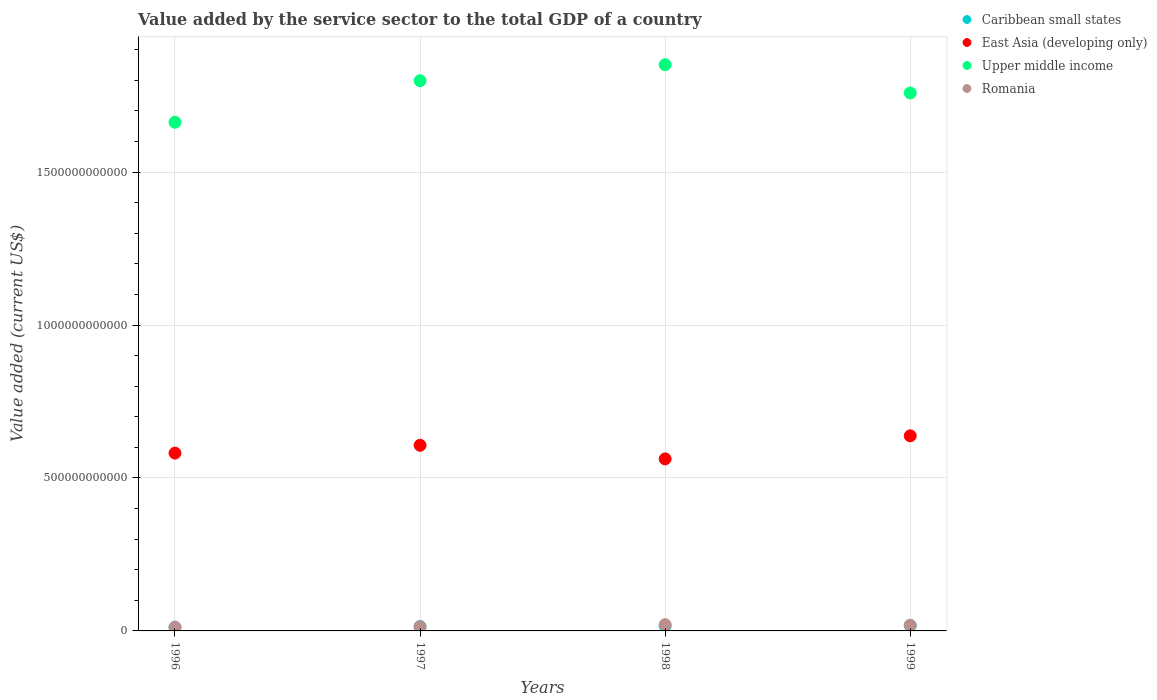How many different coloured dotlines are there?
Keep it short and to the point. 4. Is the number of dotlines equal to the number of legend labels?
Make the answer very short. Yes. What is the value added by the service sector to the total GDP in Romania in 1999?
Provide a short and direct response. 1.86e+1. Across all years, what is the maximum value added by the service sector to the total GDP in Romania?
Keep it short and to the point. 2.05e+1. Across all years, what is the minimum value added by the service sector to the total GDP in Romania?
Give a very brief answer. 1.22e+1. What is the total value added by the service sector to the total GDP in East Asia (developing only) in the graph?
Offer a very short reply. 2.39e+12. What is the difference between the value added by the service sector to the total GDP in Upper middle income in 1996 and that in 1998?
Ensure brevity in your answer.  -1.88e+11. What is the difference between the value added by the service sector to the total GDP in East Asia (developing only) in 1998 and the value added by the service sector to the total GDP in Romania in 1999?
Offer a terse response. 5.44e+11. What is the average value added by the service sector to the total GDP in Caribbean small states per year?
Offer a terse response. 1.50e+1. In the year 1996, what is the difference between the value added by the service sector to the total GDP in East Asia (developing only) and value added by the service sector to the total GDP in Romania?
Provide a short and direct response. 5.69e+11. In how many years, is the value added by the service sector to the total GDP in Upper middle income greater than 500000000000 US$?
Your answer should be compact. 4. What is the ratio of the value added by the service sector to the total GDP in Romania in 1998 to that in 1999?
Offer a terse response. 1.1. Is the value added by the service sector to the total GDP in Upper middle income in 1997 less than that in 1999?
Your response must be concise. No. Is the difference between the value added by the service sector to the total GDP in East Asia (developing only) in 1996 and 1998 greater than the difference between the value added by the service sector to the total GDP in Romania in 1996 and 1998?
Make the answer very short. Yes. What is the difference between the highest and the second highest value added by the service sector to the total GDP in East Asia (developing only)?
Provide a succinct answer. 3.09e+1. What is the difference between the highest and the lowest value added by the service sector to the total GDP in Romania?
Give a very brief answer. 8.25e+09. Is the sum of the value added by the service sector to the total GDP in Romania in 1996 and 1997 greater than the maximum value added by the service sector to the total GDP in East Asia (developing only) across all years?
Offer a very short reply. No. Is it the case that in every year, the sum of the value added by the service sector to the total GDP in Caribbean small states and value added by the service sector to the total GDP in Upper middle income  is greater than the sum of value added by the service sector to the total GDP in East Asia (developing only) and value added by the service sector to the total GDP in Romania?
Give a very brief answer. Yes. Is the value added by the service sector to the total GDP in East Asia (developing only) strictly greater than the value added by the service sector to the total GDP in Romania over the years?
Your answer should be compact. Yes. Is the value added by the service sector to the total GDP in Caribbean small states strictly less than the value added by the service sector to the total GDP in Upper middle income over the years?
Your answer should be compact. Yes. How many dotlines are there?
Your answer should be compact. 4. What is the difference between two consecutive major ticks on the Y-axis?
Your answer should be very brief. 5.00e+11. Are the values on the major ticks of Y-axis written in scientific E-notation?
Give a very brief answer. No. Does the graph contain any zero values?
Keep it short and to the point. No. Does the graph contain grids?
Give a very brief answer. Yes. Where does the legend appear in the graph?
Give a very brief answer. Top right. What is the title of the graph?
Ensure brevity in your answer.  Value added by the service sector to the total GDP of a country. Does "Sao Tome and Principe" appear as one of the legend labels in the graph?
Your answer should be compact. No. What is the label or title of the X-axis?
Give a very brief answer. Years. What is the label or title of the Y-axis?
Your response must be concise. Value added (current US$). What is the Value added (current US$) of Caribbean small states in 1996?
Your response must be concise. 1.20e+1. What is the Value added (current US$) in East Asia (developing only) in 1996?
Your answer should be compact. 5.81e+11. What is the Value added (current US$) in Upper middle income in 1996?
Give a very brief answer. 1.66e+12. What is the Value added (current US$) in Romania in 1996?
Your answer should be very brief. 1.22e+1. What is the Value added (current US$) in Caribbean small states in 1997?
Give a very brief answer. 1.42e+1. What is the Value added (current US$) in East Asia (developing only) in 1997?
Keep it short and to the point. 6.07e+11. What is the Value added (current US$) of Upper middle income in 1997?
Make the answer very short. 1.80e+12. What is the Value added (current US$) of Romania in 1997?
Give a very brief answer. 1.34e+1. What is the Value added (current US$) of Caribbean small states in 1998?
Make the answer very short. 1.63e+1. What is the Value added (current US$) in East Asia (developing only) in 1998?
Provide a short and direct response. 5.62e+11. What is the Value added (current US$) in Upper middle income in 1998?
Provide a succinct answer. 1.85e+12. What is the Value added (current US$) of Romania in 1998?
Offer a very short reply. 2.05e+1. What is the Value added (current US$) in Caribbean small states in 1999?
Your answer should be very brief. 1.74e+1. What is the Value added (current US$) in East Asia (developing only) in 1999?
Keep it short and to the point. 6.38e+11. What is the Value added (current US$) in Upper middle income in 1999?
Make the answer very short. 1.76e+12. What is the Value added (current US$) of Romania in 1999?
Offer a very short reply. 1.86e+1. Across all years, what is the maximum Value added (current US$) in Caribbean small states?
Offer a terse response. 1.74e+1. Across all years, what is the maximum Value added (current US$) in East Asia (developing only)?
Offer a very short reply. 6.38e+11. Across all years, what is the maximum Value added (current US$) in Upper middle income?
Offer a very short reply. 1.85e+12. Across all years, what is the maximum Value added (current US$) of Romania?
Your answer should be very brief. 2.05e+1. Across all years, what is the minimum Value added (current US$) of Caribbean small states?
Provide a short and direct response. 1.20e+1. Across all years, what is the minimum Value added (current US$) in East Asia (developing only)?
Your answer should be very brief. 5.62e+11. Across all years, what is the minimum Value added (current US$) of Upper middle income?
Your answer should be compact. 1.66e+12. Across all years, what is the minimum Value added (current US$) in Romania?
Your answer should be compact. 1.22e+1. What is the total Value added (current US$) of Caribbean small states in the graph?
Your answer should be very brief. 5.99e+1. What is the total Value added (current US$) in East Asia (developing only) in the graph?
Give a very brief answer. 2.39e+12. What is the total Value added (current US$) in Upper middle income in the graph?
Offer a very short reply. 7.07e+12. What is the total Value added (current US$) of Romania in the graph?
Offer a very short reply. 6.47e+1. What is the difference between the Value added (current US$) of Caribbean small states in 1996 and that in 1997?
Offer a very short reply. -2.25e+09. What is the difference between the Value added (current US$) in East Asia (developing only) in 1996 and that in 1997?
Keep it short and to the point. -2.56e+1. What is the difference between the Value added (current US$) of Upper middle income in 1996 and that in 1997?
Your response must be concise. -1.36e+11. What is the difference between the Value added (current US$) in Romania in 1996 and that in 1997?
Provide a short and direct response. -1.17e+09. What is the difference between the Value added (current US$) in Caribbean small states in 1996 and that in 1998?
Offer a very short reply. -4.38e+09. What is the difference between the Value added (current US$) in East Asia (developing only) in 1996 and that in 1998?
Provide a short and direct response. 1.90e+1. What is the difference between the Value added (current US$) in Upper middle income in 1996 and that in 1998?
Offer a very short reply. -1.88e+11. What is the difference between the Value added (current US$) in Romania in 1996 and that in 1998?
Provide a succinct answer. -8.25e+09. What is the difference between the Value added (current US$) of Caribbean small states in 1996 and that in 1999?
Make the answer very short. -5.45e+09. What is the difference between the Value added (current US$) of East Asia (developing only) in 1996 and that in 1999?
Provide a short and direct response. -5.65e+1. What is the difference between the Value added (current US$) of Upper middle income in 1996 and that in 1999?
Your answer should be very brief. -9.57e+1. What is the difference between the Value added (current US$) of Romania in 1996 and that in 1999?
Offer a very short reply. -6.42e+09. What is the difference between the Value added (current US$) in Caribbean small states in 1997 and that in 1998?
Provide a succinct answer. -2.14e+09. What is the difference between the Value added (current US$) of East Asia (developing only) in 1997 and that in 1998?
Your response must be concise. 4.46e+1. What is the difference between the Value added (current US$) of Upper middle income in 1997 and that in 1998?
Your answer should be compact. -5.24e+1. What is the difference between the Value added (current US$) in Romania in 1997 and that in 1998?
Your response must be concise. -7.08e+09. What is the difference between the Value added (current US$) of Caribbean small states in 1997 and that in 1999?
Provide a succinct answer. -3.20e+09. What is the difference between the Value added (current US$) in East Asia (developing only) in 1997 and that in 1999?
Provide a succinct answer. -3.09e+1. What is the difference between the Value added (current US$) of Upper middle income in 1997 and that in 1999?
Your response must be concise. 4.00e+1. What is the difference between the Value added (current US$) of Romania in 1997 and that in 1999?
Make the answer very short. -5.25e+09. What is the difference between the Value added (current US$) of Caribbean small states in 1998 and that in 1999?
Ensure brevity in your answer.  -1.07e+09. What is the difference between the Value added (current US$) of East Asia (developing only) in 1998 and that in 1999?
Make the answer very short. -7.55e+1. What is the difference between the Value added (current US$) in Upper middle income in 1998 and that in 1999?
Offer a terse response. 9.24e+1. What is the difference between the Value added (current US$) in Romania in 1998 and that in 1999?
Your answer should be compact. 1.83e+09. What is the difference between the Value added (current US$) of Caribbean small states in 1996 and the Value added (current US$) of East Asia (developing only) in 1997?
Give a very brief answer. -5.95e+11. What is the difference between the Value added (current US$) in Caribbean small states in 1996 and the Value added (current US$) in Upper middle income in 1997?
Provide a succinct answer. -1.79e+12. What is the difference between the Value added (current US$) of Caribbean small states in 1996 and the Value added (current US$) of Romania in 1997?
Give a very brief answer. -1.43e+09. What is the difference between the Value added (current US$) of East Asia (developing only) in 1996 and the Value added (current US$) of Upper middle income in 1997?
Make the answer very short. -1.22e+12. What is the difference between the Value added (current US$) of East Asia (developing only) in 1996 and the Value added (current US$) of Romania in 1997?
Keep it short and to the point. 5.68e+11. What is the difference between the Value added (current US$) in Upper middle income in 1996 and the Value added (current US$) in Romania in 1997?
Your answer should be very brief. 1.65e+12. What is the difference between the Value added (current US$) of Caribbean small states in 1996 and the Value added (current US$) of East Asia (developing only) in 1998?
Your response must be concise. -5.50e+11. What is the difference between the Value added (current US$) in Caribbean small states in 1996 and the Value added (current US$) in Upper middle income in 1998?
Keep it short and to the point. -1.84e+12. What is the difference between the Value added (current US$) in Caribbean small states in 1996 and the Value added (current US$) in Romania in 1998?
Your response must be concise. -8.51e+09. What is the difference between the Value added (current US$) of East Asia (developing only) in 1996 and the Value added (current US$) of Upper middle income in 1998?
Provide a short and direct response. -1.27e+12. What is the difference between the Value added (current US$) of East Asia (developing only) in 1996 and the Value added (current US$) of Romania in 1998?
Give a very brief answer. 5.61e+11. What is the difference between the Value added (current US$) of Upper middle income in 1996 and the Value added (current US$) of Romania in 1998?
Offer a terse response. 1.64e+12. What is the difference between the Value added (current US$) in Caribbean small states in 1996 and the Value added (current US$) in East Asia (developing only) in 1999?
Provide a short and direct response. -6.26e+11. What is the difference between the Value added (current US$) in Caribbean small states in 1996 and the Value added (current US$) in Upper middle income in 1999?
Ensure brevity in your answer.  -1.75e+12. What is the difference between the Value added (current US$) in Caribbean small states in 1996 and the Value added (current US$) in Romania in 1999?
Keep it short and to the point. -6.68e+09. What is the difference between the Value added (current US$) in East Asia (developing only) in 1996 and the Value added (current US$) in Upper middle income in 1999?
Provide a short and direct response. -1.18e+12. What is the difference between the Value added (current US$) in East Asia (developing only) in 1996 and the Value added (current US$) in Romania in 1999?
Provide a succinct answer. 5.63e+11. What is the difference between the Value added (current US$) in Upper middle income in 1996 and the Value added (current US$) in Romania in 1999?
Your response must be concise. 1.64e+12. What is the difference between the Value added (current US$) in Caribbean small states in 1997 and the Value added (current US$) in East Asia (developing only) in 1998?
Offer a terse response. -5.48e+11. What is the difference between the Value added (current US$) of Caribbean small states in 1997 and the Value added (current US$) of Upper middle income in 1998?
Make the answer very short. -1.84e+12. What is the difference between the Value added (current US$) in Caribbean small states in 1997 and the Value added (current US$) in Romania in 1998?
Ensure brevity in your answer.  -6.27e+09. What is the difference between the Value added (current US$) of East Asia (developing only) in 1997 and the Value added (current US$) of Upper middle income in 1998?
Your answer should be compact. -1.24e+12. What is the difference between the Value added (current US$) of East Asia (developing only) in 1997 and the Value added (current US$) of Romania in 1998?
Ensure brevity in your answer.  5.86e+11. What is the difference between the Value added (current US$) in Upper middle income in 1997 and the Value added (current US$) in Romania in 1998?
Give a very brief answer. 1.78e+12. What is the difference between the Value added (current US$) of Caribbean small states in 1997 and the Value added (current US$) of East Asia (developing only) in 1999?
Provide a short and direct response. -6.24e+11. What is the difference between the Value added (current US$) in Caribbean small states in 1997 and the Value added (current US$) in Upper middle income in 1999?
Provide a succinct answer. -1.74e+12. What is the difference between the Value added (current US$) of Caribbean small states in 1997 and the Value added (current US$) of Romania in 1999?
Your answer should be compact. -4.44e+09. What is the difference between the Value added (current US$) of East Asia (developing only) in 1997 and the Value added (current US$) of Upper middle income in 1999?
Offer a terse response. -1.15e+12. What is the difference between the Value added (current US$) in East Asia (developing only) in 1997 and the Value added (current US$) in Romania in 1999?
Keep it short and to the point. 5.88e+11. What is the difference between the Value added (current US$) of Upper middle income in 1997 and the Value added (current US$) of Romania in 1999?
Your response must be concise. 1.78e+12. What is the difference between the Value added (current US$) of Caribbean small states in 1998 and the Value added (current US$) of East Asia (developing only) in 1999?
Offer a terse response. -6.21e+11. What is the difference between the Value added (current US$) of Caribbean small states in 1998 and the Value added (current US$) of Upper middle income in 1999?
Offer a terse response. -1.74e+12. What is the difference between the Value added (current US$) in Caribbean small states in 1998 and the Value added (current US$) in Romania in 1999?
Make the answer very short. -2.30e+09. What is the difference between the Value added (current US$) in East Asia (developing only) in 1998 and the Value added (current US$) in Upper middle income in 1999?
Provide a succinct answer. -1.20e+12. What is the difference between the Value added (current US$) of East Asia (developing only) in 1998 and the Value added (current US$) of Romania in 1999?
Offer a terse response. 5.44e+11. What is the difference between the Value added (current US$) in Upper middle income in 1998 and the Value added (current US$) in Romania in 1999?
Provide a short and direct response. 1.83e+12. What is the average Value added (current US$) in Caribbean small states per year?
Keep it short and to the point. 1.50e+1. What is the average Value added (current US$) in East Asia (developing only) per year?
Give a very brief answer. 5.97e+11. What is the average Value added (current US$) in Upper middle income per year?
Provide a short and direct response. 1.77e+12. What is the average Value added (current US$) of Romania per year?
Your response must be concise. 1.62e+1. In the year 1996, what is the difference between the Value added (current US$) of Caribbean small states and Value added (current US$) of East Asia (developing only)?
Keep it short and to the point. -5.69e+11. In the year 1996, what is the difference between the Value added (current US$) in Caribbean small states and Value added (current US$) in Upper middle income?
Offer a terse response. -1.65e+12. In the year 1996, what is the difference between the Value added (current US$) in Caribbean small states and Value added (current US$) in Romania?
Your answer should be very brief. -2.60e+08. In the year 1996, what is the difference between the Value added (current US$) of East Asia (developing only) and Value added (current US$) of Upper middle income?
Your answer should be compact. -1.08e+12. In the year 1996, what is the difference between the Value added (current US$) in East Asia (developing only) and Value added (current US$) in Romania?
Your answer should be compact. 5.69e+11. In the year 1996, what is the difference between the Value added (current US$) in Upper middle income and Value added (current US$) in Romania?
Your answer should be compact. 1.65e+12. In the year 1997, what is the difference between the Value added (current US$) of Caribbean small states and Value added (current US$) of East Asia (developing only)?
Your answer should be very brief. -5.93e+11. In the year 1997, what is the difference between the Value added (current US$) in Caribbean small states and Value added (current US$) in Upper middle income?
Your response must be concise. -1.78e+12. In the year 1997, what is the difference between the Value added (current US$) in Caribbean small states and Value added (current US$) in Romania?
Ensure brevity in your answer.  8.14e+08. In the year 1997, what is the difference between the Value added (current US$) of East Asia (developing only) and Value added (current US$) of Upper middle income?
Ensure brevity in your answer.  -1.19e+12. In the year 1997, what is the difference between the Value added (current US$) in East Asia (developing only) and Value added (current US$) in Romania?
Provide a succinct answer. 5.94e+11. In the year 1997, what is the difference between the Value added (current US$) in Upper middle income and Value added (current US$) in Romania?
Ensure brevity in your answer.  1.79e+12. In the year 1998, what is the difference between the Value added (current US$) in Caribbean small states and Value added (current US$) in East Asia (developing only)?
Make the answer very short. -5.46e+11. In the year 1998, what is the difference between the Value added (current US$) in Caribbean small states and Value added (current US$) in Upper middle income?
Give a very brief answer. -1.83e+12. In the year 1998, what is the difference between the Value added (current US$) of Caribbean small states and Value added (current US$) of Romania?
Your answer should be very brief. -4.13e+09. In the year 1998, what is the difference between the Value added (current US$) of East Asia (developing only) and Value added (current US$) of Upper middle income?
Keep it short and to the point. -1.29e+12. In the year 1998, what is the difference between the Value added (current US$) of East Asia (developing only) and Value added (current US$) of Romania?
Keep it short and to the point. 5.42e+11. In the year 1998, what is the difference between the Value added (current US$) of Upper middle income and Value added (current US$) of Romania?
Your response must be concise. 1.83e+12. In the year 1999, what is the difference between the Value added (current US$) in Caribbean small states and Value added (current US$) in East Asia (developing only)?
Your response must be concise. -6.20e+11. In the year 1999, what is the difference between the Value added (current US$) in Caribbean small states and Value added (current US$) in Upper middle income?
Your response must be concise. -1.74e+12. In the year 1999, what is the difference between the Value added (current US$) of Caribbean small states and Value added (current US$) of Romania?
Provide a succinct answer. -1.23e+09. In the year 1999, what is the difference between the Value added (current US$) in East Asia (developing only) and Value added (current US$) in Upper middle income?
Your response must be concise. -1.12e+12. In the year 1999, what is the difference between the Value added (current US$) in East Asia (developing only) and Value added (current US$) in Romania?
Your answer should be very brief. 6.19e+11. In the year 1999, what is the difference between the Value added (current US$) in Upper middle income and Value added (current US$) in Romania?
Provide a short and direct response. 1.74e+12. What is the ratio of the Value added (current US$) of Caribbean small states in 1996 to that in 1997?
Your answer should be very brief. 0.84. What is the ratio of the Value added (current US$) in East Asia (developing only) in 1996 to that in 1997?
Give a very brief answer. 0.96. What is the ratio of the Value added (current US$) in Upper middle income in 1996 to that in 1997?
Your answer should be very brief. 0.92. What is the ratio of the Value added (current US$) in Romania in 1996 to that in 1997?
Your answer should be very brief. 0.91. What is the ratio of the Value added (current US$) in Caribbean small states in 1996 to that in 1998?
Your response must be concise. 0.73. What is the ratio of the Value added (current US$) of East Asia (developing only) in 1996 to that in 1998?
Your response must be concise. 1.03. What is the ratio of the Value added (current US$) in Upper middle income in 1996 to that in 1998?
Provide a succinct answer. 0.9. What is the ratio of the Value added (current US$) in Romania in 1996 to that in 1998?
Your answer should be compact. 0.6. What is the ratio of the Value added (current US$) of Caribbean small states in 1996 to that in 1999?
Offer a terse response. 0.69. What is the ratio of the Value added (current US$) of East Asia (developing only) in 1996 to that in 1999?
Your response must be concise. 0.91. What is the ratio of the Value added (current US$) in Upper middle income in 1996 to that in 1999?
Keep it short and to the point. 0.95. What is the ratio of the Value added (current US$) in Romania in 1996 to that in 1999?
Your answer should be very brief. 0.66. What is the ratio of the Value added (current US$) in Caribbean small states in 1997 to that in 1998?
Your answer should be compact. 0.87. What is the ratio of the Value added (current US$) of East Asia (developing only) in 1997 to that in 1998?
Provide a succinct answer. 1.08. What is the ratio of the Value added (current US$) in Upper middle income in 1997 to that in 1998?
Make the answer very short. 0.97. What is the ratio of the Value added (current US$) in Romania in 1997 to that in 1998?
Keep it short and to the point. 0.65. What is the ratio of the Value added (current US$) in Caribbean small states in 1997 to that in 1999?
Give a very brief answer. 0.82. What is the ratio of the Value added (current US$) in East Asia (developing only) in 1997 to that in 1999?
Offer a very short reply. 0.95. What is the ratio of the Value added (current US$) in Upper middle income in 1997 to that in 1999?
Keep it short and to the point. 1.02. What is the ratio of the Value added (current US$) in Romania in 1997 to that in 1999?
Your answer should be very brief. 0.72. What is the ratio of the Value added (current US$) of Caribbean small states in 1998 to that in 1999?
Your response must be concise. 0.94. What is the ratio of the Value added (current US$) in East Asia (developing only) in 1998 to that in 1999?
Offer a terse response. 0.88. What is the ratio of the Value added (current US$) of Upper middle income in 1998 to that in 1999?
Provide a succinct answer. 1.05. What is the ratio of the Value added (current US$) in Romania in 1998 to that in 1999?
Offer a very short reply. 1.1. What is the difference between the highest and the second highest Value added (current US$) in Caribbean small states?
Provide a succinct answer. 1.07e+09. What is the difference between the highest and the second highest Value added (current US$) in East Asia (developing only)?
Provide a short and direct response. 3.09e+1. What is the difference between the highest and the second highest Value added (current US$) in Upper middle income?
Keep it short and to the point. 5.24e+1. What is the difference between the highest and the second highest Value added (current US$) in Romania?
Your answer should be compact. 1.83e+09. What is the difference between the highest and the lowest Value added (current US$) of Caribbean small states?
Your response must be concise. 5.45e+09. What is the difference between the highest and the lowest Value added (current US$) of East Asia (developing only)?
Offer a terse response. 7.55e+1. What is the difference between the highest and the lowest Value added (current US$) in Upper middle income?
Keep it short and to the point. 1.88e+11. What is the difference between the highest and the lowest Value added (current US$) in Romania?
Your answer should be compact. 8.25e+09. 